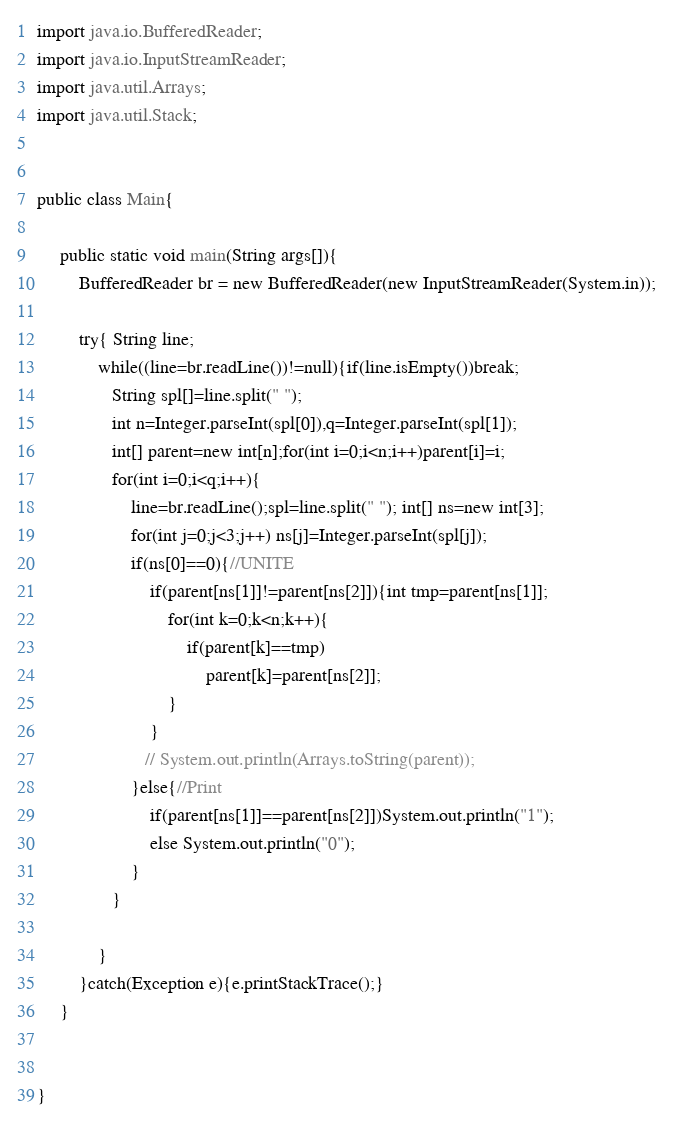<code> <loc_0><loc_0><loc_500><loc_500><_Java_>


import java.io.BufferedReader;
import java.io.InputStreamReader;
import java.util.Arrays;
import java.util.Stack;
 

public class Main{
          
     public static void main(String args[]){
         BufferedReader br = new BufferedReader(new InputStreamReader(System.in));
         
         try{ String line;
             while((line=br.readLine())!=null){if(line.isEmpty())break;
                String spl[]=line.split(" ");
                int n=Integer.parseInt(spl[0]),q=Integer.parseInt(spl[1]);
                int[] parent=new int[n];for(int i=0;i<n;i++)parent[i]=i;
                for(int i=0;i<q;i++){
                    line=br.readLine();spl=line.split(" "); int[] ns=new int[3];
                    for(int j=0;j<3;j++) ns[j]=Integer.parseInt(spl[j]);
                    if(ns[0]==0){//UNITE
                        if(parent[ns[1]]!=parent[ns[2]]){int tmp=parent[ns[1]];
                            for(int k=0;k<n;k++){
                                if(parent[k]==tmp)
                                    parent[k]=parent[ns[2]];
                            }
                        }
                       // System.out.println(Arrays.toString(parent));
                    }else{//Print
                        if(parent[ns[1]]==parent[ns[2]])System.out.println("1");
                        else System.out.println("0");
                    }
                }
                
             }
         }catch(Exception e){e.printStackTrace();}         
     }  
     
     
}</code> 